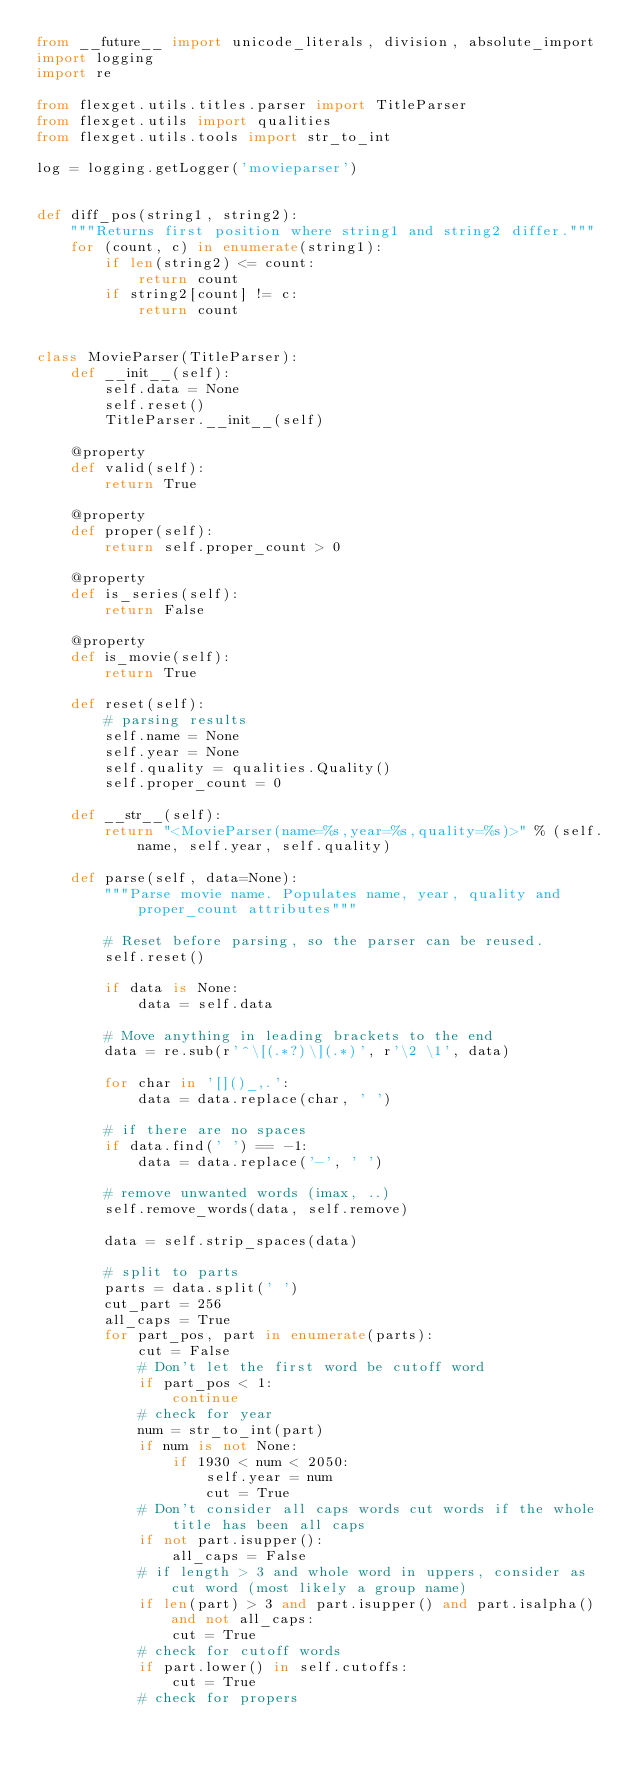<code> <loc_0><loc_0><loc_500><loc_500><_Python_>from __future__ import unicode_literals, division, absolute_import
import logging
import re

from flexget.utils.titles.parser import TitleParser
from flexget.utils import qualities
from flexget.utils.tools import str_to_int

log = logging.getLogger('movieparser')


def diff_pos(string1, string2):
    """Returns first position where string1 and string2 differ."""
    for (count, c) in enumerate(string1):
        if len(string2) <= count:
            return count
        if string2[count] != c:
            return count


class MovieParser(TitleParser):
    def __init__(self):
        self.data = None
        self.reset()
        TitleParser.__init__(self)

    @property
    def valid(self):
        return True

    @property
    def proper(self):
        return self.proper_count > 0

    @property
    def is_series(self):
        return False

    @property
    def is_movie(self):
        return True

    def reset(self):
        # parsing results
        self.name = None
        self.year = None
        self.quality = qualities.Quality()
        self.proper_count = 0

    def __str__(self):
        return "<MovieParser(name=%s,year=%s,quality=%s)>" % (self.name, self.year, self.quality)

    def parse(self, data=None):
        """Parse movie name. Populates name, year, quality and proper_count attributes"""

        # Reset before parsing, so the parser can be reused.
        self.reset()

        if data is None:
            data = self.data

        # Move anything in leading brackets to the end
        data = re.sub(r'^\[(.*?)\](.*)', r'\2 \1', data)

        for char in '[]()_,.':
            data = data.replace(char, ' ')

        # if there are no spaces
        if data.find(' ') == -1:
            data = data.replace('-', ' ')

        # remove unwanted words (imax, ..)
        self.remove_words(data, self.remove)

        data = self.strip_spaces(data)

        # split to parts
        parts = data.split(' ')
        cut_part = 256
        all_caps = True
        for part_pos, part in enumerate(parts):
            cut = False
            # Don't let the first word be cutoff word
            if part_pos < 1:
                continue
            # check for year
            num = str_to_int(part)
            if num is not None:
                if 1930 < num < 2050:
                    self.year = num
                    cut = True
            # Don't consider all caps words cut words if the whole title has been all caps
            if not part.isupper():
                all_caps = False
            # if length > 3 and whole word in uppers, consider as cut word (most likely a group name)
            if len(part) > 3 and part.isupper() and part.isalpha() and not all_caps:
                cut = True
            # check for cutoff words
            if part.lower() in self.cutoffs:
                cut = True
            # check for propers</code> 